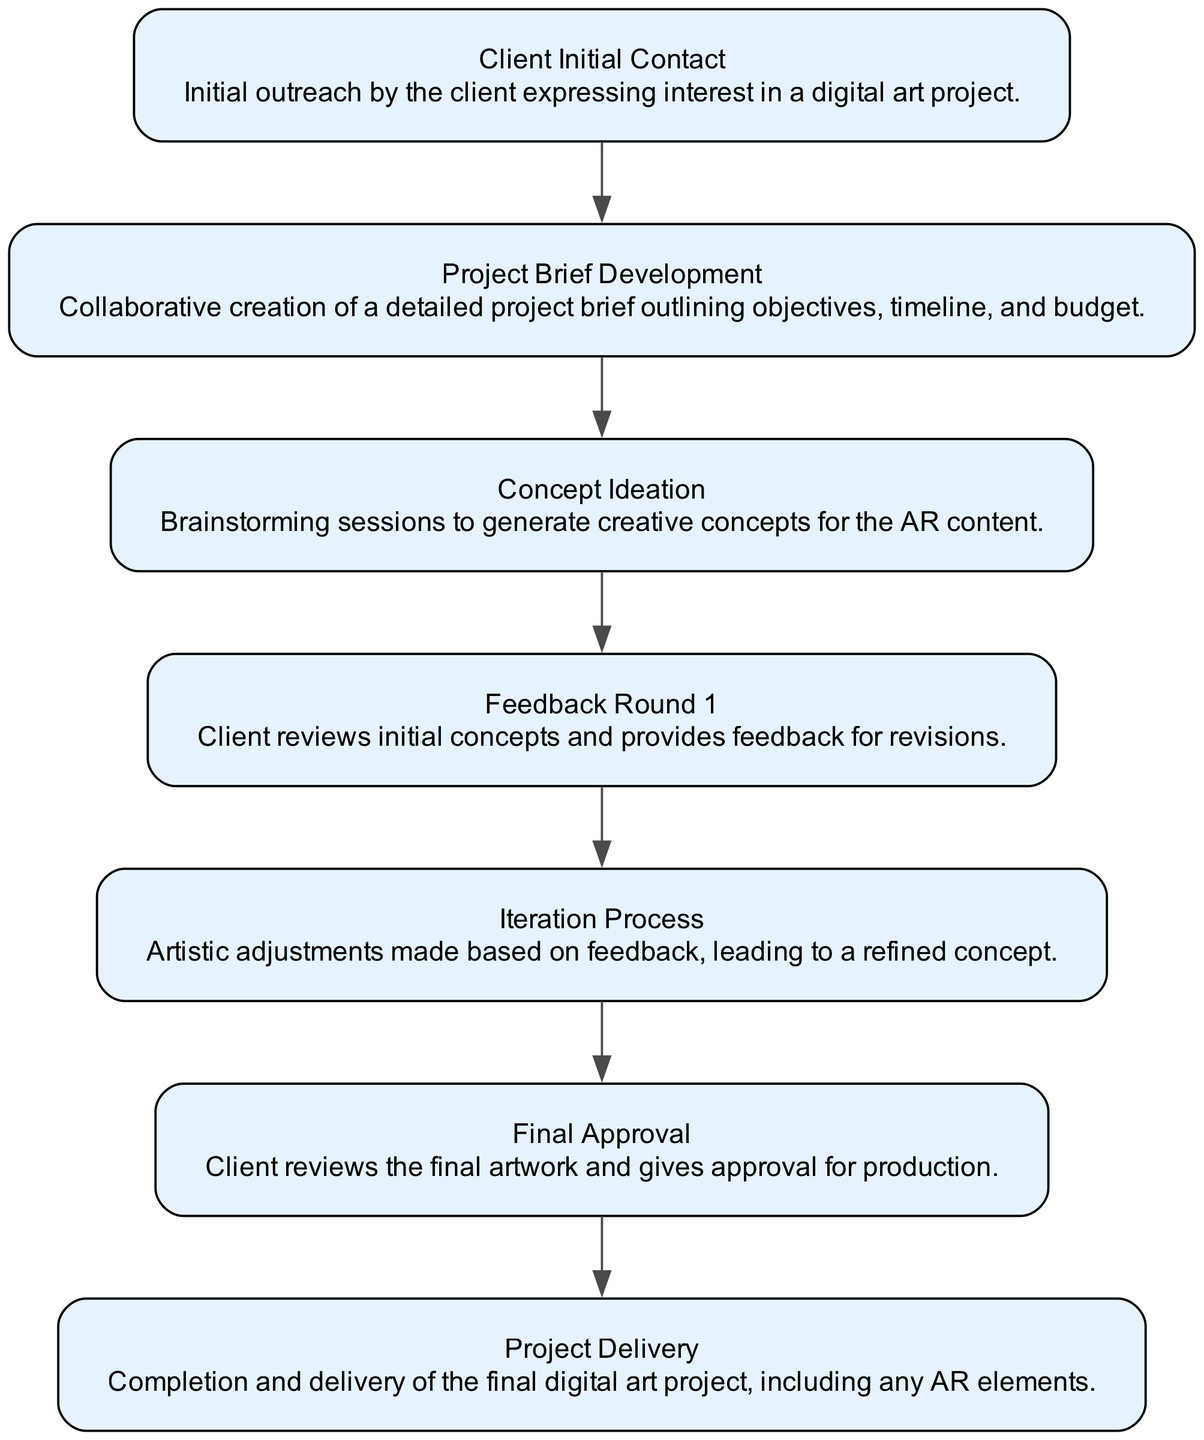What is the first step in the workflow? The diagram indicates that the first step is "Client Initial Contact," as it is the first node presented in the flow.
Answer: Client Initial Contact How many steps are involved in the workflow? By counting the total number of nodes in the diagram, which represent each step, there are 7 steps in total.
Answer: 7 Which step comes after "Concept Ideation"? According to the flow of the diagram, the step following "Concept Ideation" is "Feedback Round 1." This can be confirmed by tracing the arrows from one step to the next.
Answer: Feedback Round 1 What is the last step shown in the diagram? The final node in the diagram is "Project Delivery," which signifies the completion of the workflow. This is visually identified as the last node without outgoing connections.
Answer: Project Delivery How many iterations occur before the final approval? The workflow specifies one iteration in the process where feedback is incorporated before reaching "Final Approval," meaning there is one cycle of adjustments based on client feedback.
Answer: 1 What activity occurs during the "Iteration Process"? During the "Iteration Process," artistic adjustments are made based on the client's feedback received earlier in the workflow, refining the concept further before seeking final approval.
Answer: Artistic adjustments What is the relationship between "Feedback Round 1" and "Iteration Process"? The relationship is sequential; "Feedback Round 1" leads directly into the "Iteration Process" as feedback from the client is used to inform changes made during the iteration. This can be observed through the connecting arrow in the diagram.
Answer: Sequential relationship 